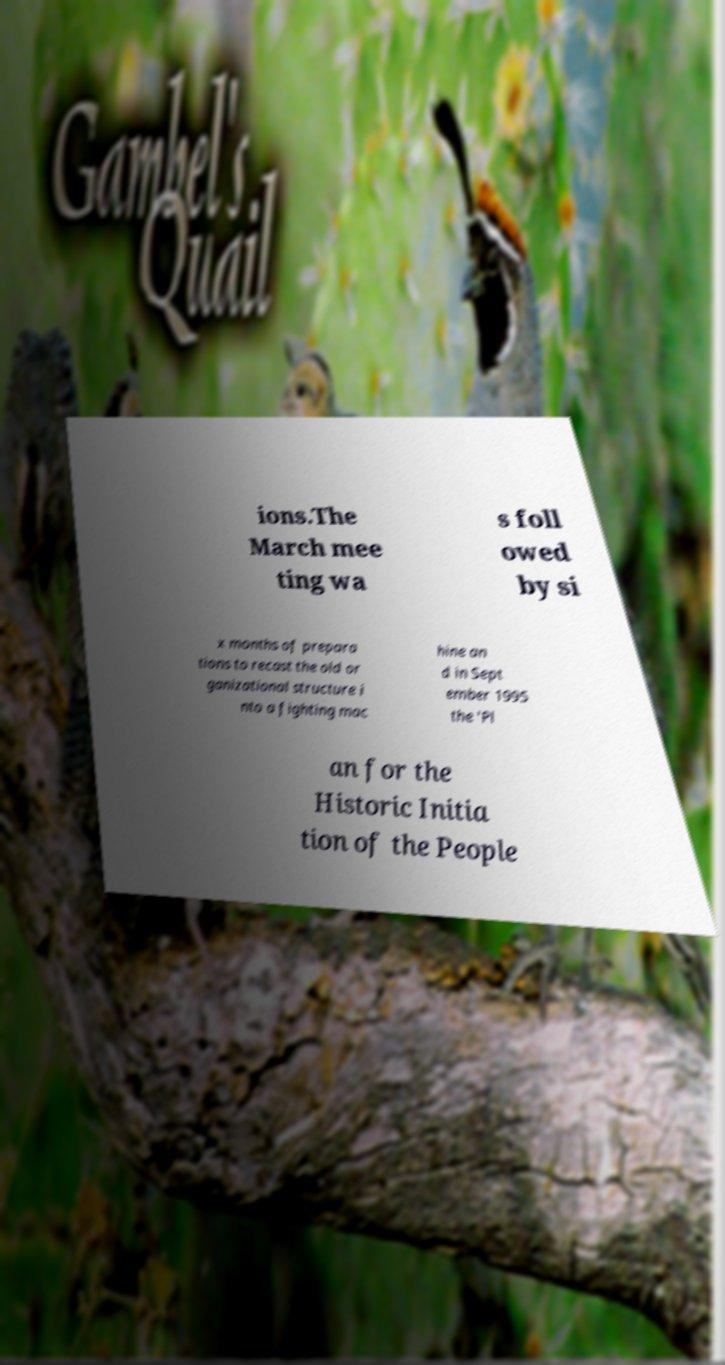There's text embedded in this image that I need extracted. Can you transcribe it verbatim? ions.The March mee ting wa s foll owed by si x months of prepara tions to recast the old or ganizational structure i nto a fighting mac hine an d in Sept ember 1995 the 'Pl an for the Historic Initia tion of the People 